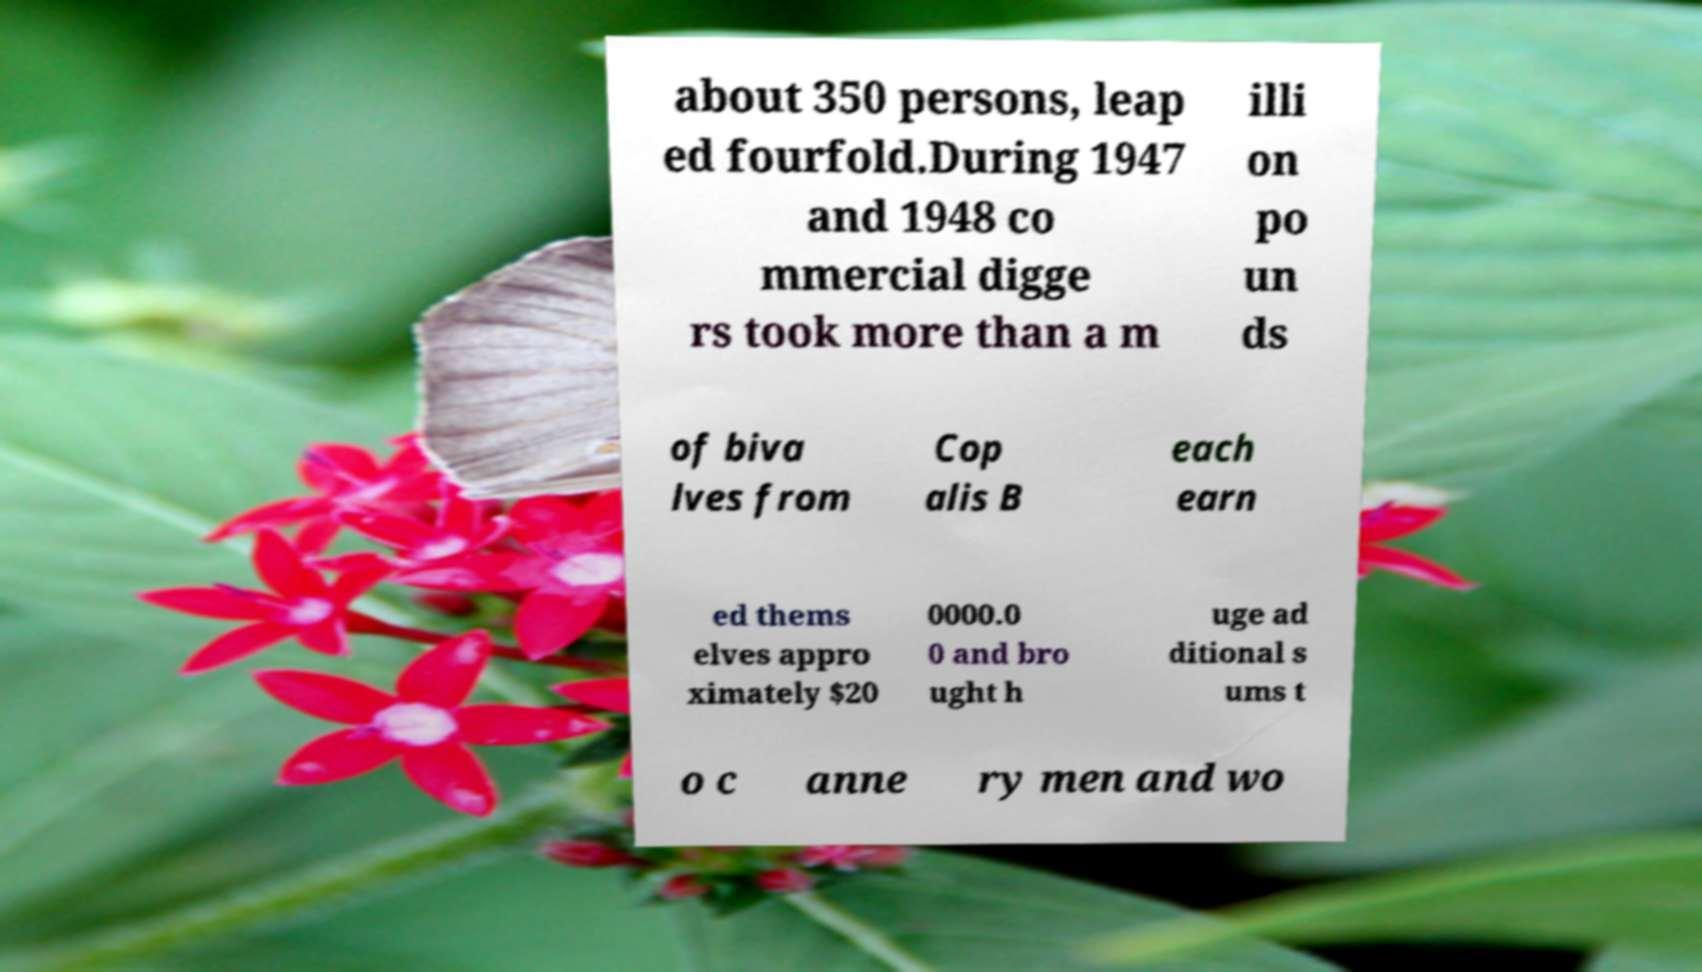Please read and relay the text visible in this image. What does it say? about 350 persons, leap ed fourfold.During 1947 and 1948 co mmercial digge rs took more than a m illi on po un ds of biva lves from Cop alis B each earn ed thems elves appro ximately $20 0000.0 0 and bro ught h uge ad ditional s ums t o c anne ry men and wo 